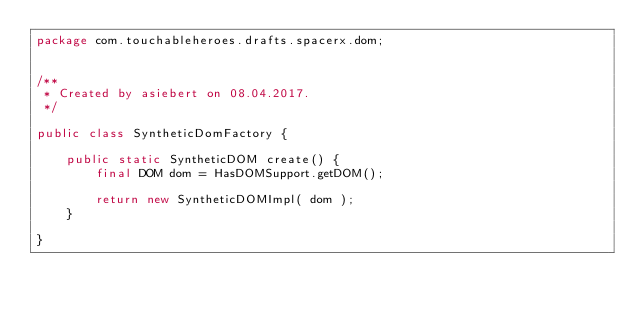<code> <loc_0><loc_0><loc_500><loc_500><_Java_>package com.touchableheroes.drafts.spacerx.dom;


/**
 * Created by asiebert on 08.04.2017.
 */

public class SyntheticDomFactory {

    public static SyntheticDOM create() {
        final DOM dom = HasDOMSupport.getDOM();

        return new SyntheticDOMImpl( dom );
    }

}
</code> 